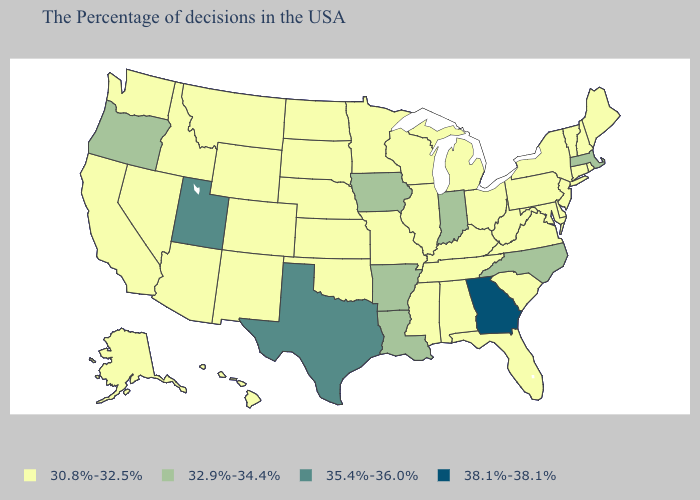What is the lowest value in the USA?
Answer briefly. 30.8%-32.5%. Name the states that have a value in the range 38.1%-38.1%?
Be succinct. Georgia. Among the states that border Colorado , does Utah have the lowest value?
Concise answer only. No. How many symbols are there in the legend?
Be succinct. 4. What is the value of North Carolina?
Be succinct. 32.9%-34.4%. What is the value of Louisiana?
Be succinct. 32.9%-34.4%. Which states have the lowest value in the USA?
Be succinct. Maine, Rhode Island, New Hampshire, Vermont, Connecticut, New York, New Jersey, Delaware, Maryland, Pennsylvania, Virginia, South Carolina, West Virginia, Ohio, Florida, Michigan, Kentucky, Alabama, Tennessee, Wisconsin, Illinois, Mississippi, Missouri, Minnesota, Kansas, Nebraska, Oklahoma, South Dakota, North Dakota, Wyoming, Colorado, New Mexico, Montana, Arizona, Idaho, Nevada, California, Washington, Alaska, Hawaii. Name the states that have a value in the range 32.9%-34.4%?
Answer briefly. Massachusetts, North Carolina, Indiana, Louisiana, Arkansas, Iowa, Oregon. What is the highest value in states that border Idaho?
Write a very short answer. 35.4%-36.0%. Which states hav the highest value in the South?
Quick response, please. Georgia. What is the value of Minnesota?
Answer briefly. 30.8%-32.5%. Name the states that have a value in the range 32.9%-34.4%?
Quick response, please. Massachusetts, North Carolina, Indiana, Louisiana, Arkansas, Iowa, Oregon. Which states hav the highest value in the Northeast?
Answer briefly. Massachusetts. Name the states that have a value in the range 38.1%-38.1%?
Answer briefly. Georgia. Does Missouri have the same value as New Mexico?
Short answer required. Yes. 